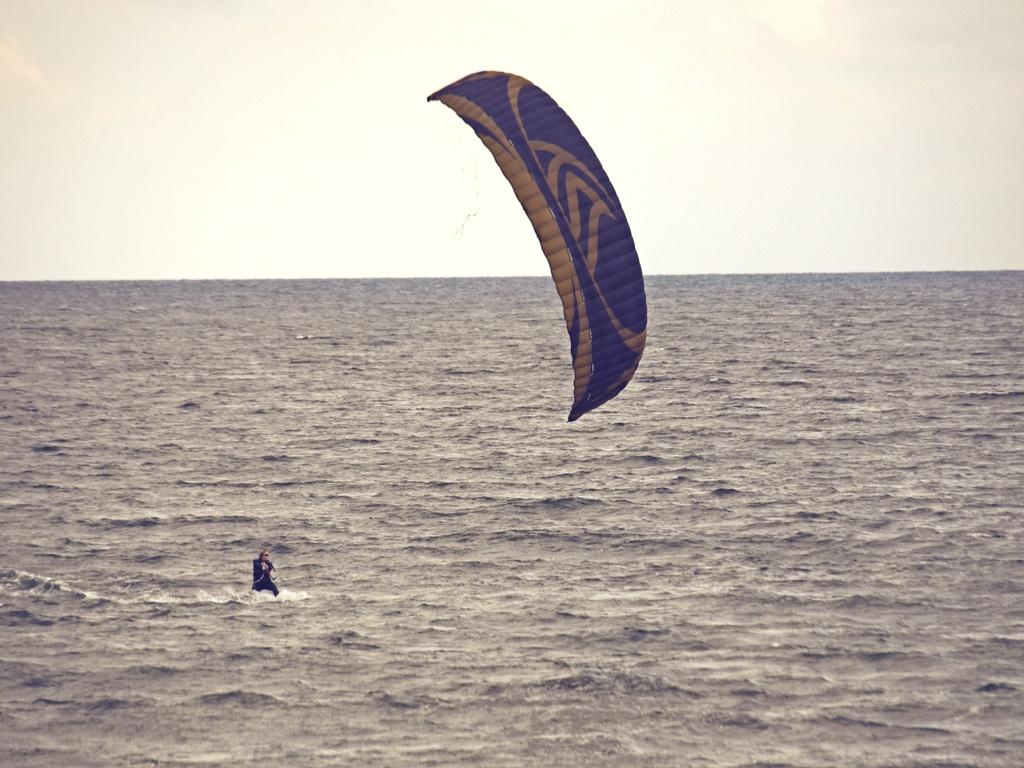What is the main setting of the image? The image depicts a sea. What activity is the person in the image engaged in? The person is para surfing in the image. What equipment is the person using for para surfing? The person is using a parachute for para surfing. What can be seen at the top of the image? The sky is visible at the top of the image. What can be seen at the bottom of the image? Water is visible at the bottom of the image. How many spiders are crawling on the person's parachute in the image? There are no spiders visible on the person's parachute in the image. What type of power source is used for the person's para surfing equipment in the image? The image does not provide information about the power source for the person's para surfing equipment. 